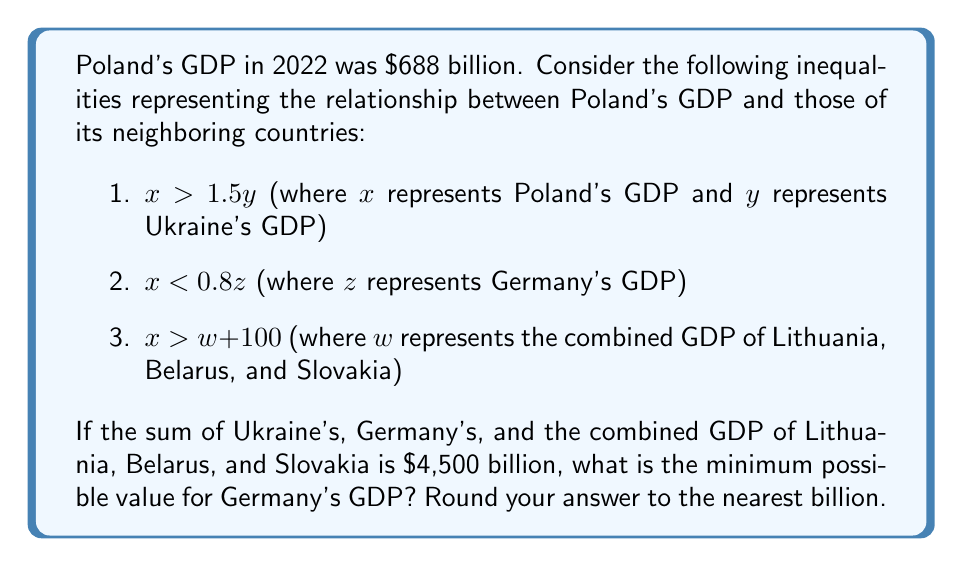Provide a solution to this math problem. Let's approach this step-by-step:

1) We know that Poland's GDP ($x$) is $688 billion.

2) From the first inequality: $x > 1.5y$
   $688 > 1.5y$
   $y < 458.67$ billion (Ukraine's GDP)

3) From the second inequality: $x < 0.8z$
   $688 < 0.8z$
   $z > 860$ billion (Germany's GDP)

4) From the third inequality: $x > w + 100$
   $688 > w + 100$
   $w < 588$ billion (combined GDP of Lithuania, Belarus, and Slovakia)

5) We're told that $y + z + w = 4500$ billion

6) To minimize $z$, we need to maximize $y$ and $w$ within their constraints:
   $y ≈ 458$ billion (rounded down)
   $w = 588$ billion

7) Therefore:
   $458 + z + 588 = 4500$
   $z = 4500 - 458 - 588 = 3454$ billion

8) This satisfies the inequality $z > 860$ billion from step 3.

9) Rounding to the nearest billion: $3454 ≈ 3454$ billion
Answer: $3454 billion 